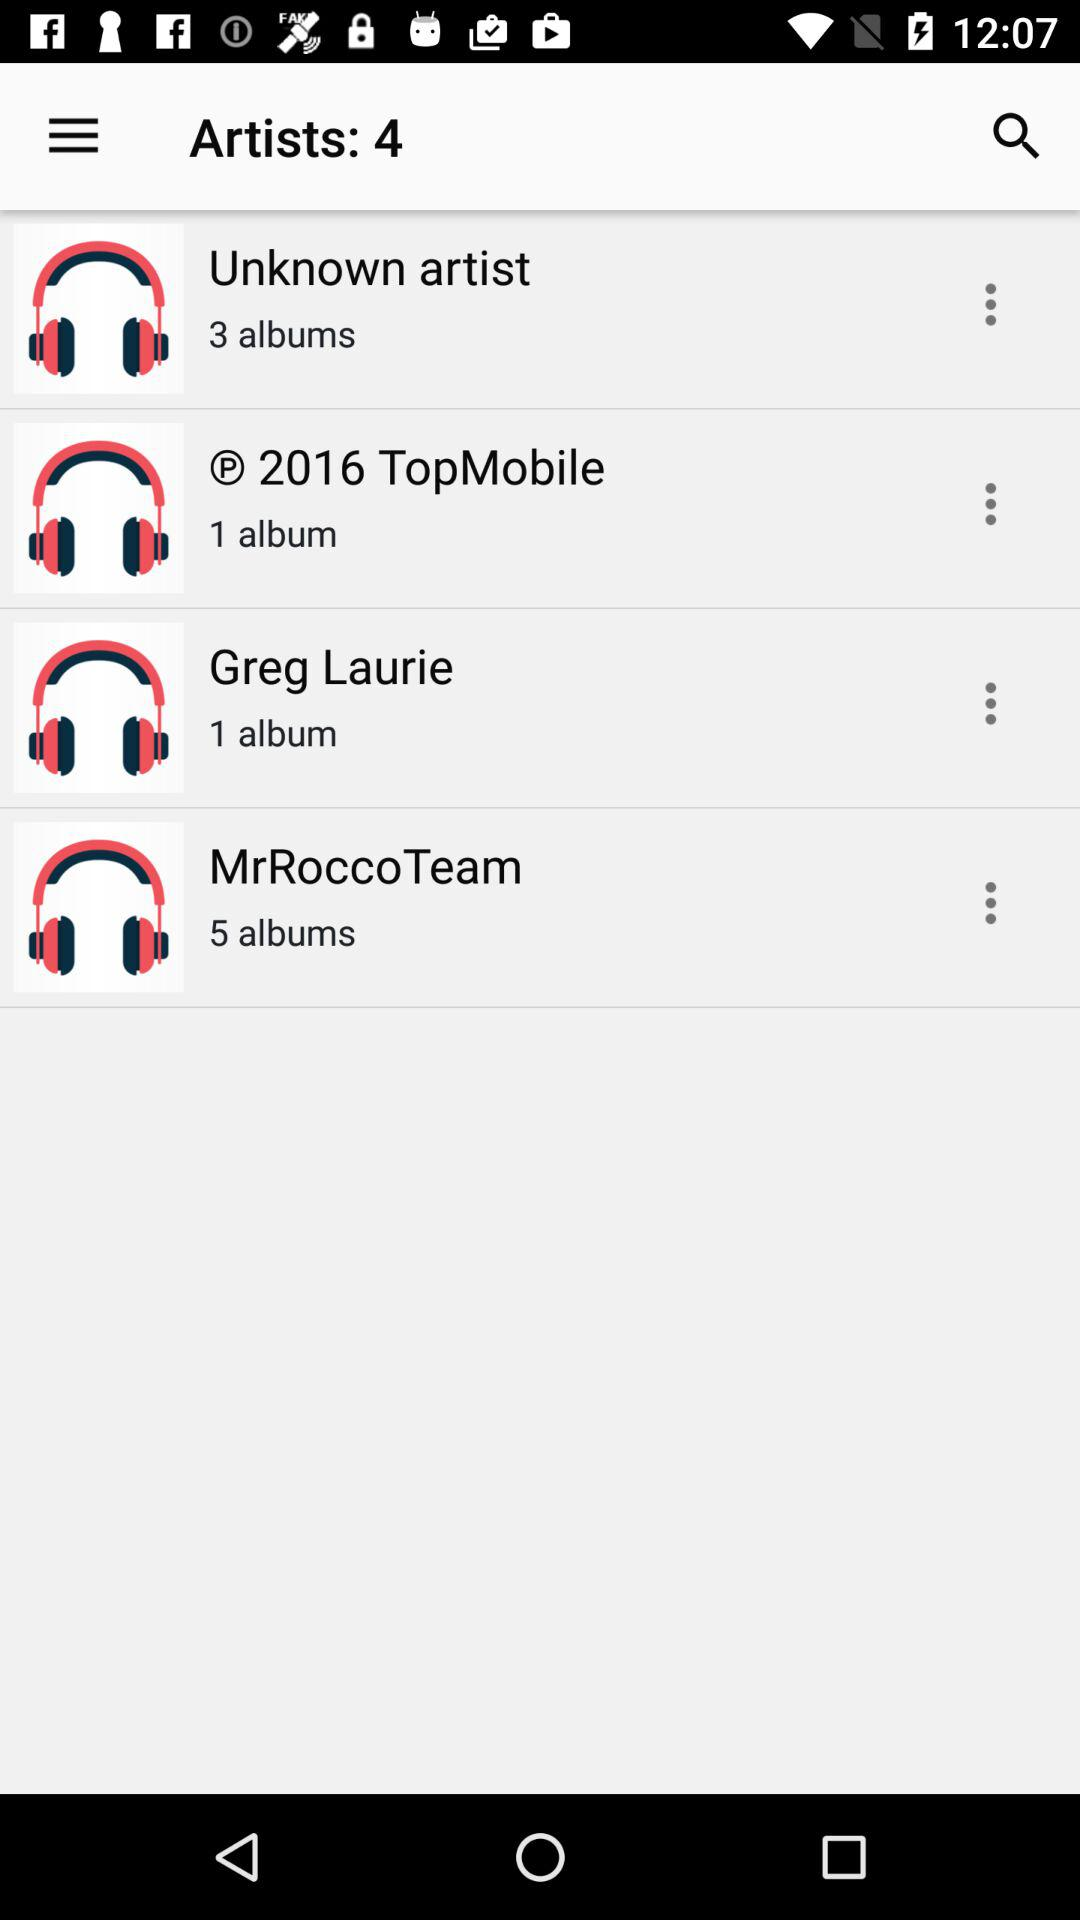What is the number of albums by "Unknown artist"? The number of albums by "Unknown artist" is 3. 